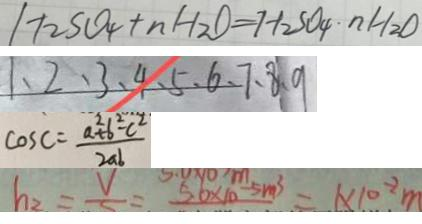<formula> <loc_0><loc_0><loc_500><loc_500>H _ { 2 } S O _ { 4 } + n H _ { 2 } O = H _ { 2 } S O _ { 4 } \cdot n H _ { 2 } O 
 1 、 2 、 3 、 4 、 5 、 6 、 7 、 8 、 9 
 \cos C = \frac { a ^ { 2 } + b ^ { 2 } - c ^ { 2 } } { 2 a b } 
 h _ { 2 } = \frac { V } { S } = 5 . 6 \times 1 0 ^ { - 5 } m ^ { 3 } = 1 \times 1 0 ^ { - 2 } m</formula> 